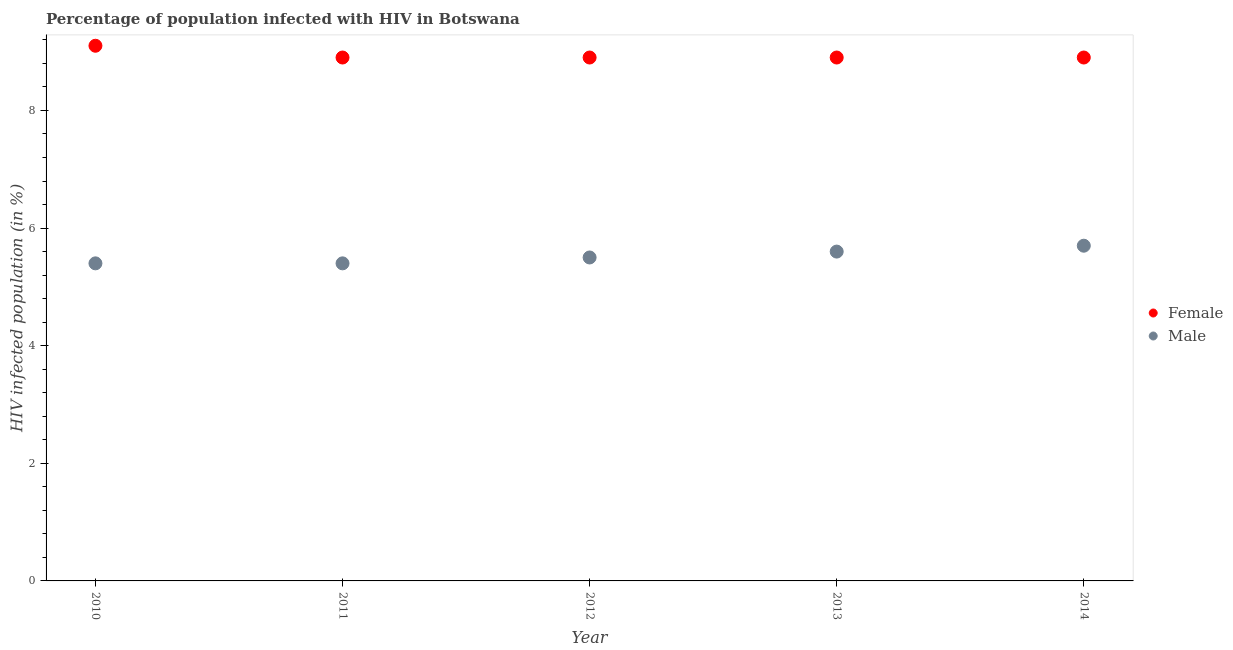Is the number of dotlines equal to the number of legend labels?
Keep it short and to the point. Yes. Across all years, what is the maximum percentage of females who are infected with hiv?
Your answer should be compact. 9.1. In which year was the percentage of females who are infected with hiv maximum?
Offer a terse response. 2010. In which year was the percentage of males who are infected with hiv minimum?
Make the answer very short. 2010. What is the total percentage of males who are infected with hiv in the graph?
Keep it short and to the point. 27.6. What is the difference between the percentage of males who are infected with hiv in 2013 and that in 2014?
Ensure brevity in your answer.  -0.1. What is the average percentage of males who are infected with hiv per year?
Your response must be concise. 5.52. What is the ratio of the percentage of males who are infected with hiv in 2011 to that in 2014?
Keep it short and to the point. 0.95. Is the percentage of females who are infected with hiv in 2012 less than that in 2013?
Your response must be concise. No. What is the difference between the highest and the second highest percentage of males who are infected with hiv?
Your response must be concise. 0.1. What is the difference between the highest and the lowest percentage of males who are infected with hiv?
Offer a terse response. 0.3. Is the percentage of females who are infected with hiv strictly less than the percentage of males who are infected with hiv over the years?
Give a very brief answer. No. How many years are there in the graph?
Keep it short and to the point. 5. Are the values on the major ticks of Y-axis written in scientific E-notation?
Your answer should be very brief. No. How many legend labels are there?
Offer a terse response. 2. How are the legend labels stacked?
Offer a terse response. Vertical. What is the title of the graph?
Your answer should be compact. Percentage of population infected with HIV in Botswana. Does "Savings" appear as one of the legend labels in the graph?
Give a very brief answer. No. What is the label or title of the Y-axis?
Provide a short and direct response. HIV infected population (in %). What is the HIV infected population (in %) in Female in 2010?
Provide a succinct answer. 9.1. What is the HIV infected population (in %) in Male in 2010?
Your answer should be very brief. 5.4. What is the HIV infected population (in %) in Male in 2011?
Provide a short and direct response. 5.4. What is the HIV infected population (in %) of Female in 2013?
Your answer should be compact. 8.9. What is the HIV infected population (in %) in Female in 2014?
Provide a succinct answer. 8.9. What is the HIV infected population (in %) of Male in 2014?
Offer a very short reply. 5.7. Across all years, what is the minimum HIV infected population (in %) in Male?
Give a very brief answer. 5.4. What is the total HIV infected population (in %) in Female in the graph?
Offer a very short reply. 44.7. What is the total HIV infected population (in %) of Male in the graph?
Make the answer very short. 27.6. What is the difference between the HIV infected population (in %) of Female in 2010 and that in 2011?
Offer a very short reply. 0.2. What is the difference between the HIV infected population (in %) of Female in 2010 and that in 2012?
Your answer should be very brief. 0.2. What is the difference between the HIV infected population (in %) of Female in 2010 and that in 2013?
Your response must be concise. 0.2. What is the difference between the HIV infected population (in %) in Female in 2010 and that in 2014?
Ensure brevity in your answer.  0.2. What is the difference between the HIV infected population (in %) in Male in 2010 and that in 2014?
Your answer should be very brief. -0.3. What is the difference between the HIV infected population (in %) in Female in 2011 and that in 2012?
Offer a very short reply. 0. What is the difference between the HIV infected population (in %) in Female in 2011 and that in 2013?
Provide a succinct answer. 0. What is the difference between the HIV infected population (in %) in Female in 2012 and that in 2013?
Your answer should be compact. 0. What is the difference between the HIV infected population (in %) in Male in 2012 and that in 2013?
Provide a succinct answer. -0.1. What is the difference between the HIV infected population (in %) in Female in 2012 and that in 2014?
Provide a succinct answer. 0. What is the difference between the HIV infected population (in %) of Male in 2013 and that in 2014?
Provide a succinct answer. -0.1. What is the difference between the HIV infected population (in %) in Female in 2010 and the HIV infected population (in %) in Male in 2011?
Keep it short and to the point. 3.7. What is the difference between the HIV infected population (in %) of Female in 2011 and the HIV infected population (in %) of Male in 2014?
Your response must be concise. 3.2. What is the difference between the HIV infected population (in %) of Female in 2012 and the HIV infected population (in %) of Male in 2013?
Give a very brief answer. 3.3. What is the difference between the HIV infected population (in %) of Female in 2012 and the HIV infected population (in %) of Male in 2014?
Keep it short and to the point. 3.2. What is the average HIV infected population (in %) in Female per year?
Ensure brevity in your answer.  8.94. What is the average HIV infected population (in %) in Male per year?
Your answer should be compact. 5.52. In the year 2010, what is the difference between the HIV infected population (in %) of Female and HIV infected population (in %) of Male?
Offer a terse response. 3.7. In the year 2011, what is the difference between the HIV infected population (in %) in Female and HIV infected population (in %) in Male?
Your answer should be very brief. 3.5. In the year 2012, what is the difference between the HIV infected population (in %) in Female and HIV infected population (in %) in Male?
Offer a terse response. 3.4. In the year 2013, what is the difference between the HIV infected population (in %) of Female and HIV infected population (in %) of Male?
Your answer should be compact. 3.3. What is the ratio of the HIV infected population (in %) in Female in 2010 to that in 2011?
Your answer should be very brief. 1.02. What is the ratio of the HIV infected population (in %) in Female in 2010 to that in 2012?
Offer a terse response. 1.02. What is the ratio of the HIV infected population (in %) in Male in 2010 to that in 2012?
Give a very brief answer. 0.98. What is the ratio of the HIV infected population (in %) of Female in 2010 to that in 2013?
Provide a short and direct response. 1.02. What is the ratio of the HIV infected population (in %) of Female in 2010 to that in 2014?
Offer a terse response. 1.02. What is the ratio of the HIV infected population (in %) of Female in 2011 to that in 2012?
Give a very brief answer. 1. What is the ratio of the HIV infected population (in %) of Male in 2011 to that in 2012?
Provide a short and direct response. 0.98. What is the ratio of the HIV infected population (in %) of Female in 2011 to that in 2013?
Your response must be concise. 1. What is the ratio of the HIV infected population (in %) of Female in 2012 to that in 2013?
Ensure brevity in your answer.  1. What is the ratio of the HIV infected population (in %) of Male in 2012 to that in 2013?
Make the answer very short. 0.98. What is the ratio of the HIV infected population (in %) of Female in 2012 to that in 2014?
Make the answer very short. 1. What is the ratio of the HIV infected population (in %) of Male in 2012 to that in 2014?
Offer a terse response. 0.96. What is the ratio of the HIV infected population (in %) of Male in 2013 to that in 2014?
Give a very brief answer. 0.98. What is the difference between the highest and the lowest HIV infected population (in %) in Female?
Make the answer very short. 0.2. What is the difference between the highest and the lowest HIV infected population (in %) of Male?
Offer a terse response. 0.3. 